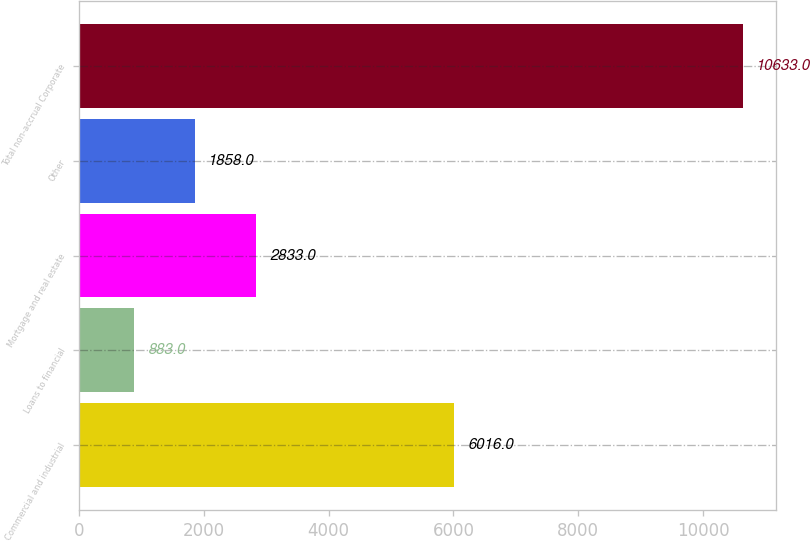Convert chart. <chart><loc_0><loc_0><loc_500><loc_500><bar_chart><fcel>Commercial and industrial<fcel>Loans to financial<fcel>Mortgage and real estate<fcel>Other<fcel>Total non-accrual Corporate<nl><fcel>6016<fcel>883<fcel>2833<fcel>1858<fcel>10633<nl></chart> 